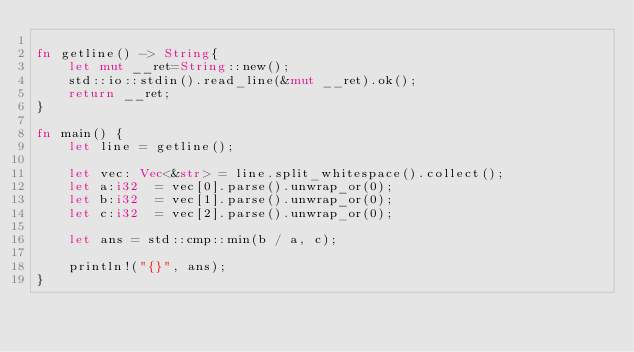<code> <loc_0><loc_0><loc_500><loc_500><_Rust_>
fn getline() -> String{
	let mut __ret=String::new();
	std::io::stdin().read_line(&mut __ret).ok();
	return __ret;
}

fn main() {
    let line = getline();

    let vec: Vec<&str> = line.split_whitespace().collect();
    let a:i32  = vec[0].parse().unwrap_or(0);
    let b:i32  = vec[1].parse().unwrap_or(0);
    let c:i32  = vec[2].parse().unwrap_or(0);

    let ans = std::cmp::min(b / a, c);

    println!("{}", ans);
}</code> 